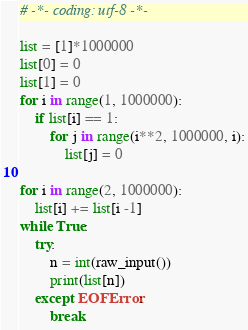Convert code to text. <code><loc_0><loc_0><loc_500><loc_500><_Python_># -*- coding: utf-8 -*-

list = [1]*1000000
list[0] = 0
list[1] = 0
for i in range(1, 1000000):
    if list[i] == 1:
        for j in range(i**2, 1000000, i):
            list[j] = 0

for i in range(2, 1000000):
    list[i] += list[i -1]
while True:
    try:
        n = int(raw_input())
        print(list[n])
    except EOFError:
        break</code> 